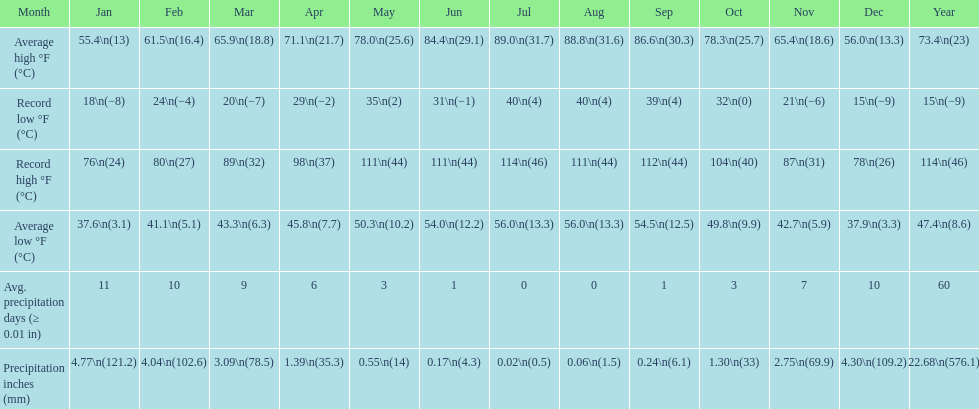Which month had an average high of 89.0 degrees and an average low of 56.0 degrees? July. 